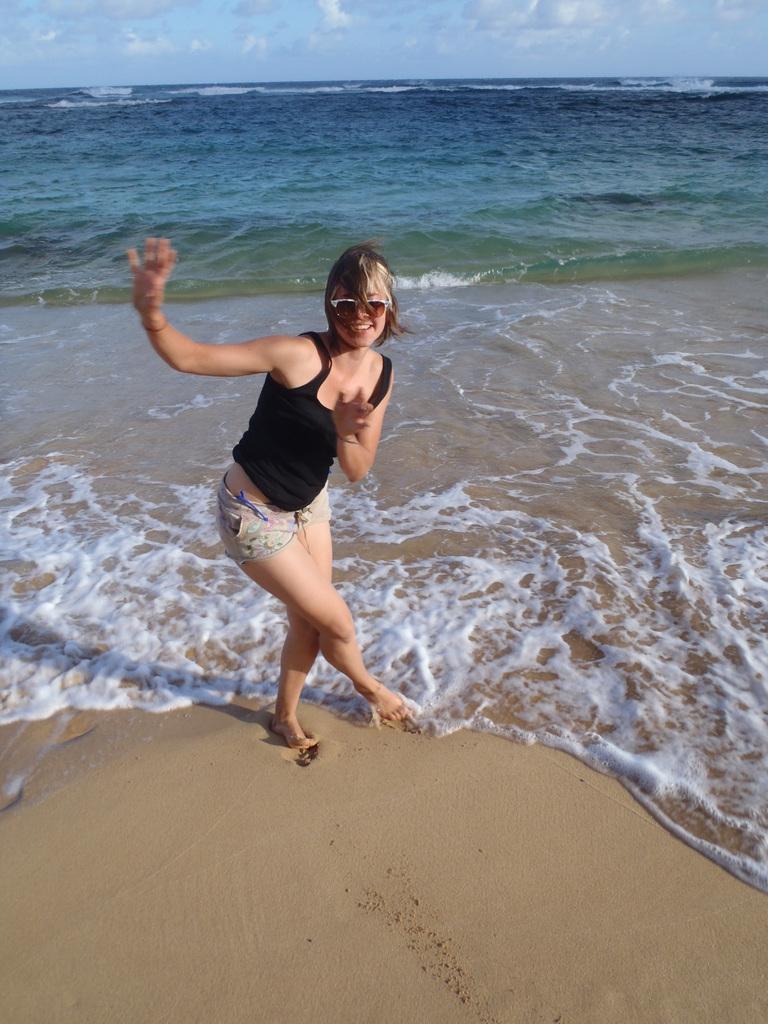Please provide a concise description of this image. A woman is standing wearing a black vest and shorts. There is water at the back. 